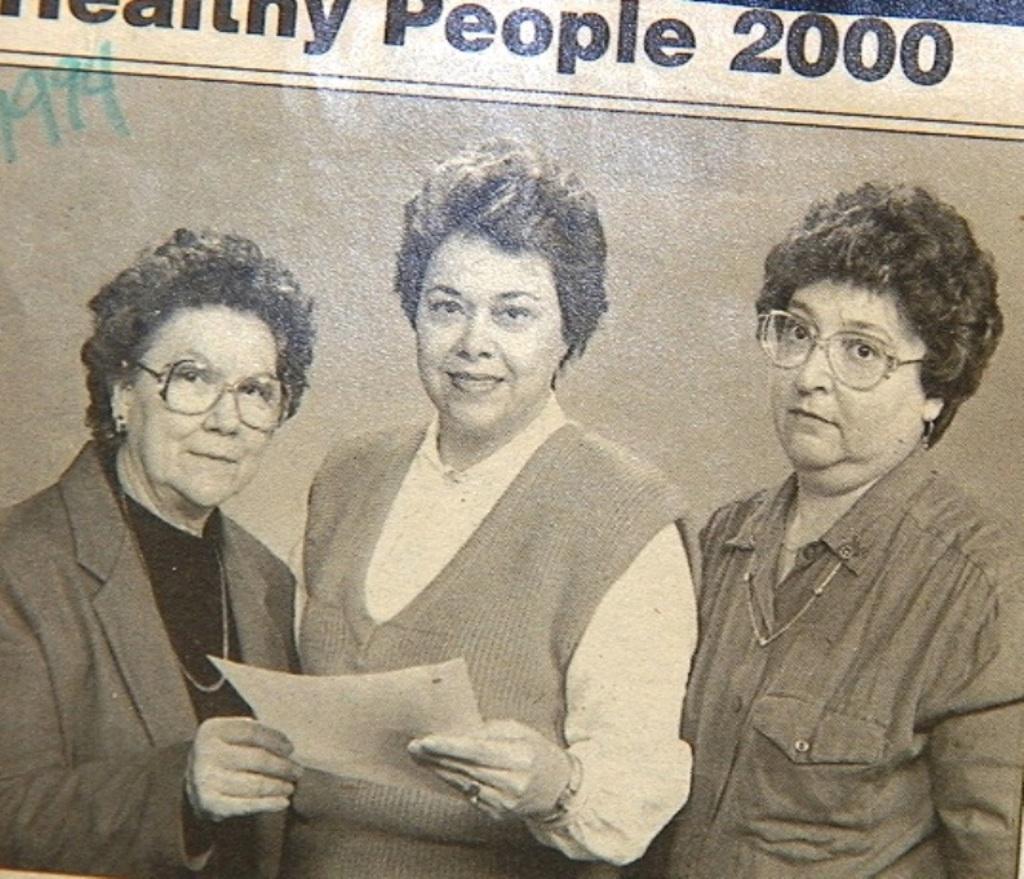Can you describe this image briefly? In this picture I can see a paper, there is a image of three persons standing, there is a person holding a paper and there are words, numbers on the paper. 